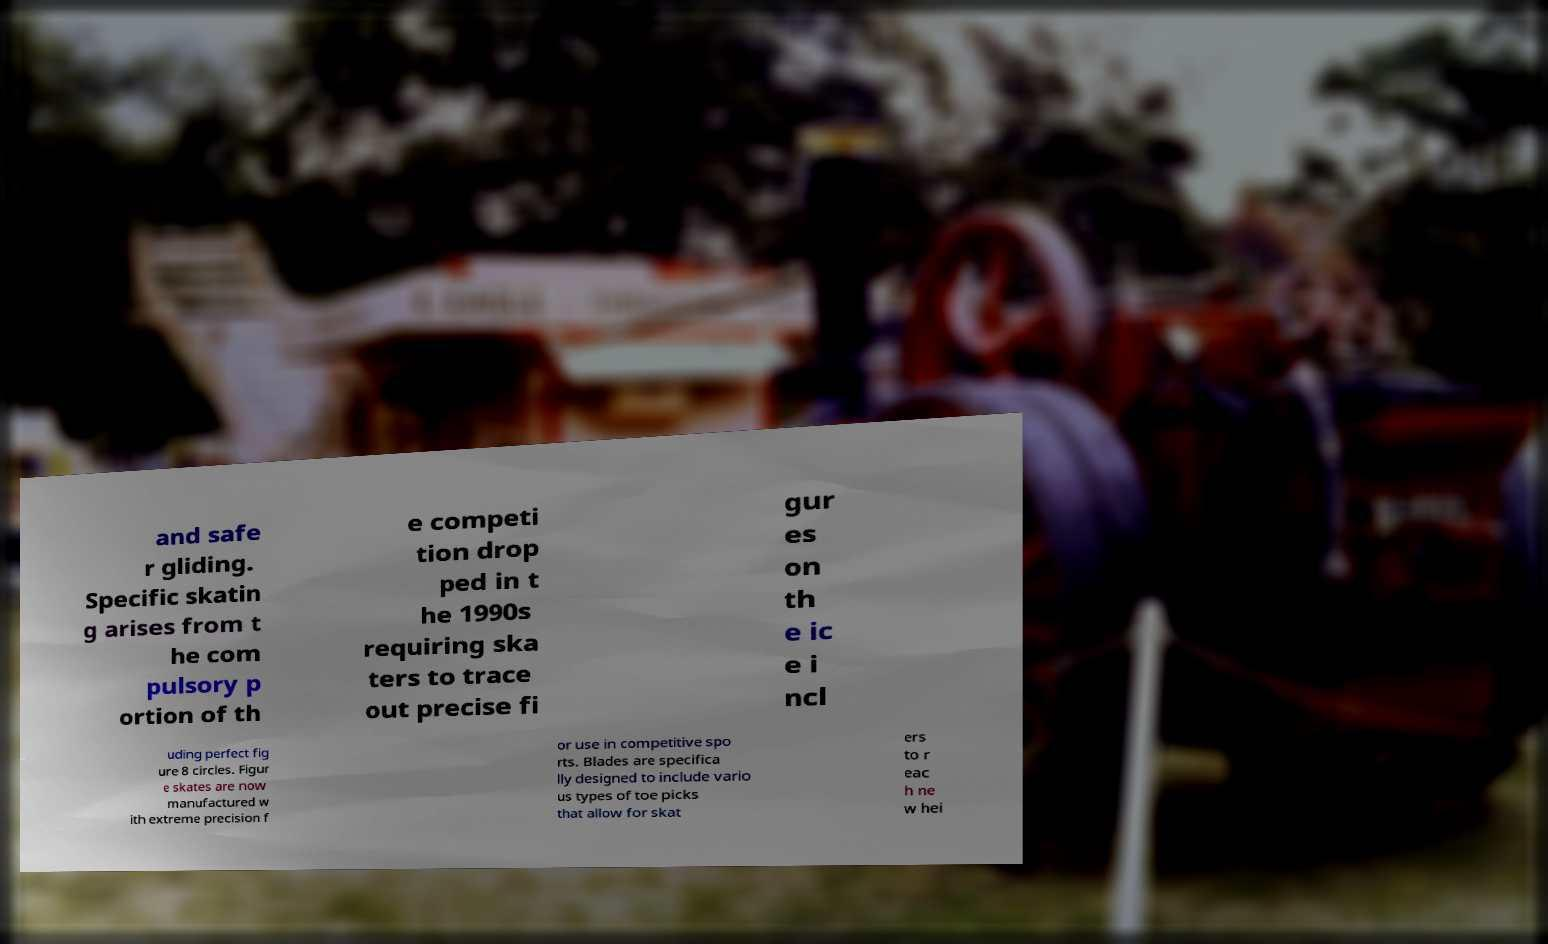Can you read and provide the text displayed in the image?This photo seems to have some interesting text. Can you extract and type it out for me? and safe r gliding. Specific skatin g arises from t he com pulsory p ortion of th e competi tion drop ped in t he 1990s requiring ska ters to trace out precise fi gur es on th e ic e i ncl uding perfect fig ure 8 circles. Figur e skates are now manufactured w ith extreme precision f or use in competitive spo rts. Blades are specifica lly designed to include vario us types of toe picks that allow for skat ers to r eac h ne w hei 